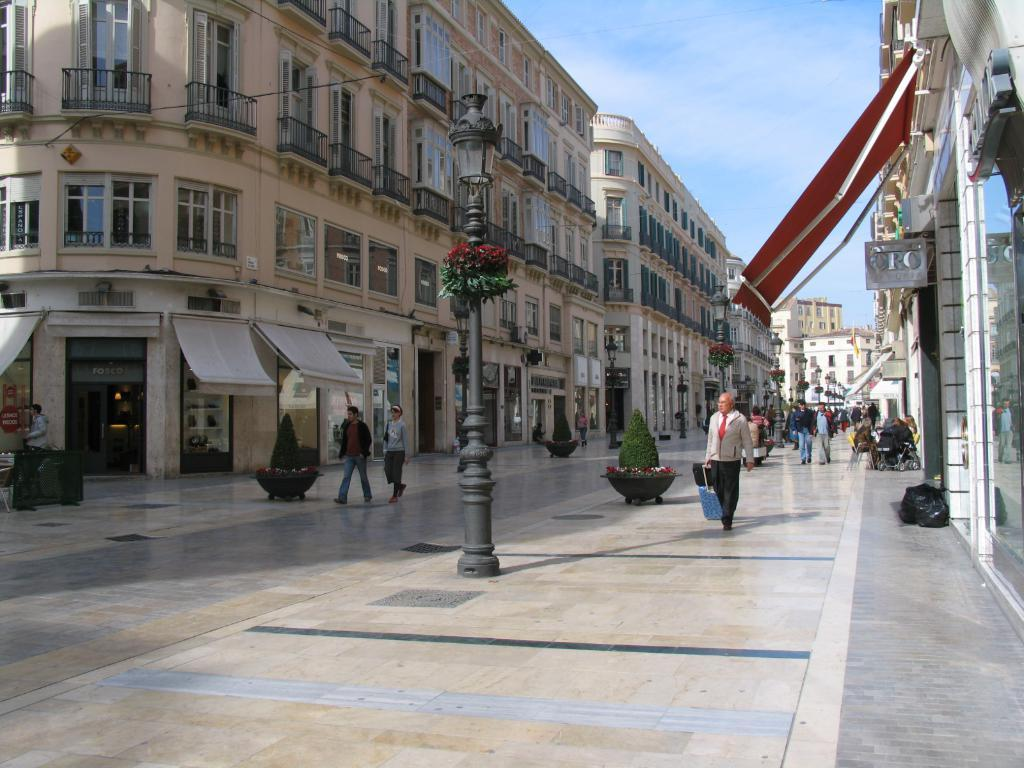What is located in the foreground of the image? There is a pole in the foreground of the image. What are the people in the image doing? There are persons walking on the side path in the image. What can be seen in the background of the image? In the background of the image, there are plants, trees, a shed, and the sky. What is the condition of the sky in the image? The sky is visible in the background of the image, and there are clouds present. What type of key is being used to unlock the shed in the image? There is no key or shed being unlocked in the image; it only shows a pole, people walking, and various background elements. What toys are being played with by the persons walking in the image? There are no toys visible in the image; the persons are simply walking on the side path. 